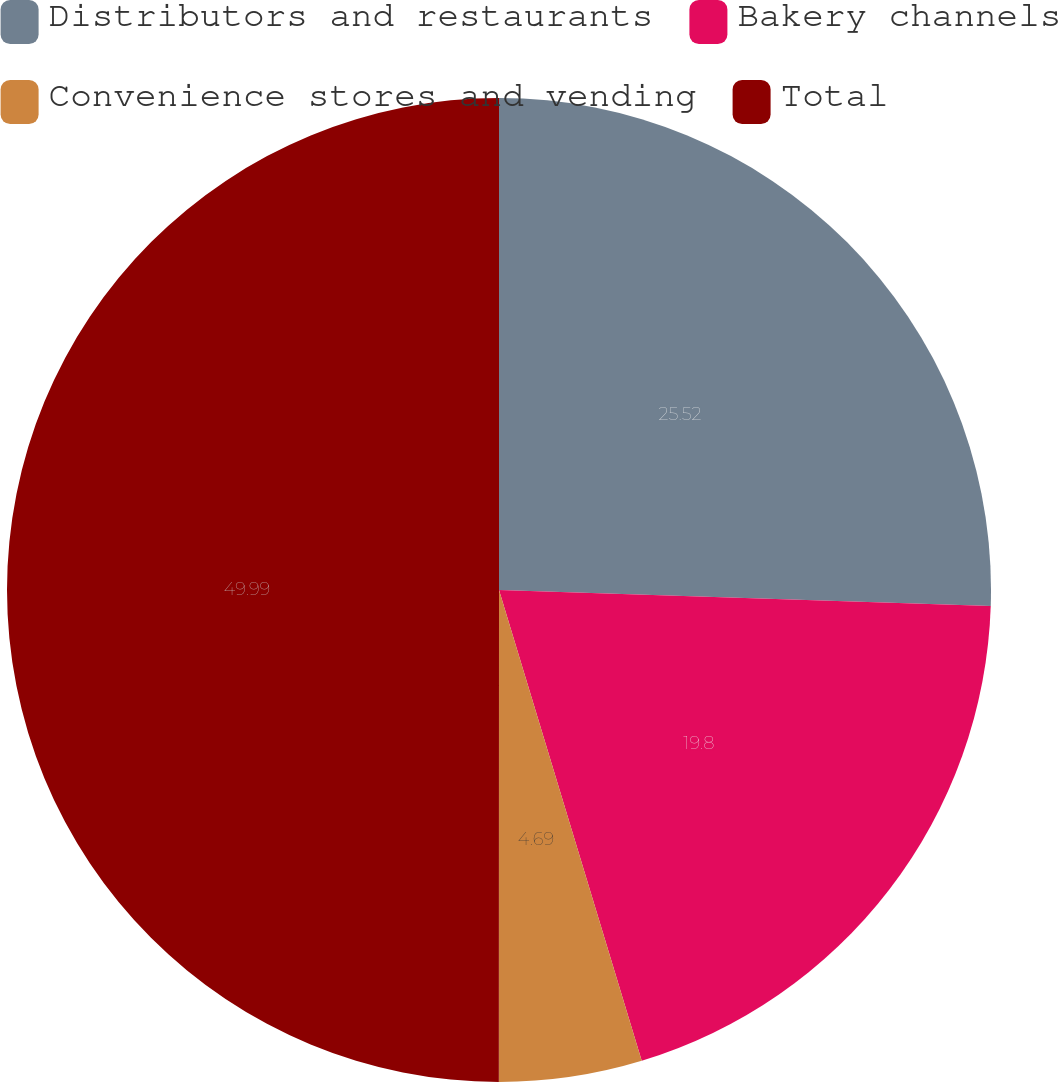<chart> <loc_0><loc_0><loc_500><loc_500><pie_chart><fcel>Distributors and restaurants<fcel>Bakery channels<fcel>Convenience stores and vending<fcel>Total<nl><fcel>25.52%<fcel>19.8%<fcel>4.69%<fcel>50.0%<nl></chart> 